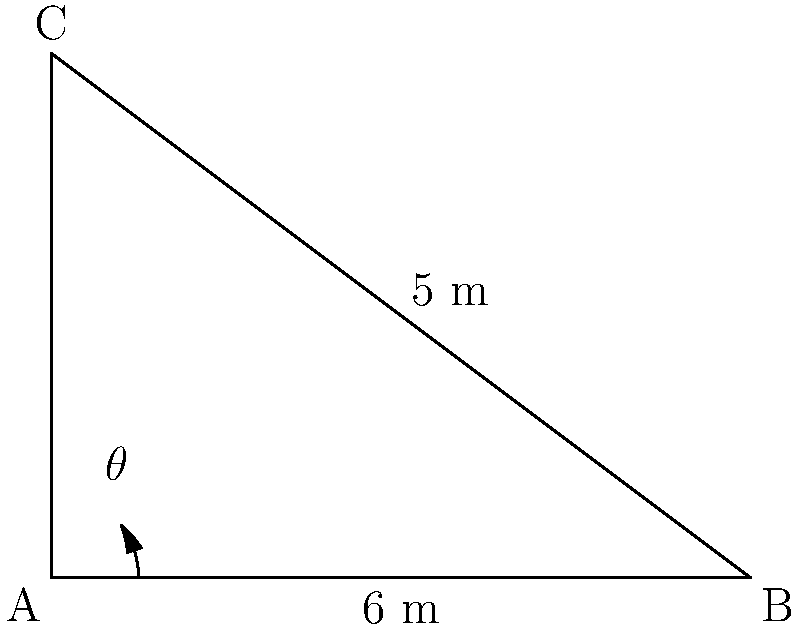In the courthouse, two hallways intersect at point A as shown in the diagram. One hallway extends from point A to point B with a length of 6 meters, while the other extends from point A to point C with a length of 5 meters. If the distance between points B and C is 5 meters, what is the angle $\theta$ (in degrees) between these two hallways? To solve this problem, we can use the law of cosines. Let's approach this step-by-step:

1) We have a triangle ABC where:
   AB = 6 meters
   AC = 5 meters
   BC = 5 meters

2) The angle we're looking for is $\theta$ at point A.

3) The law of cosines states:
   $c^2 = a^2 + b^2 - 2ab \cos(C)$
   where C is the angle opposite the side c.

4) In our case:
   $BC^2 = AB^2 + AC^2 - 2(AB)(AC)\cos(\theta)$

5) Substituting the known values:
   $5^2 = 6^2 + 5^2 - 2(6)(5)\cos(\theta)$

6) Simplify:
   $25 = 36 + 25 - 60\cos(\theta)$

7) Subtract 61 from both sides:
   $-36 = -60\cos(\theta)$

8) Divide both sides by -60:
   $\frac{3}{5} = \cos(\theta)$

9) Take the inverse cosine (arccos) of both sides:
   $\theta = \arccos(\frac{3}{5})$

10) Calculate:
    $\theta \approx 53.13$ degrees

Therefore, the angle between the two hallways is approximately 53.13 degrees.
Answer: $53.13^\circ$ 